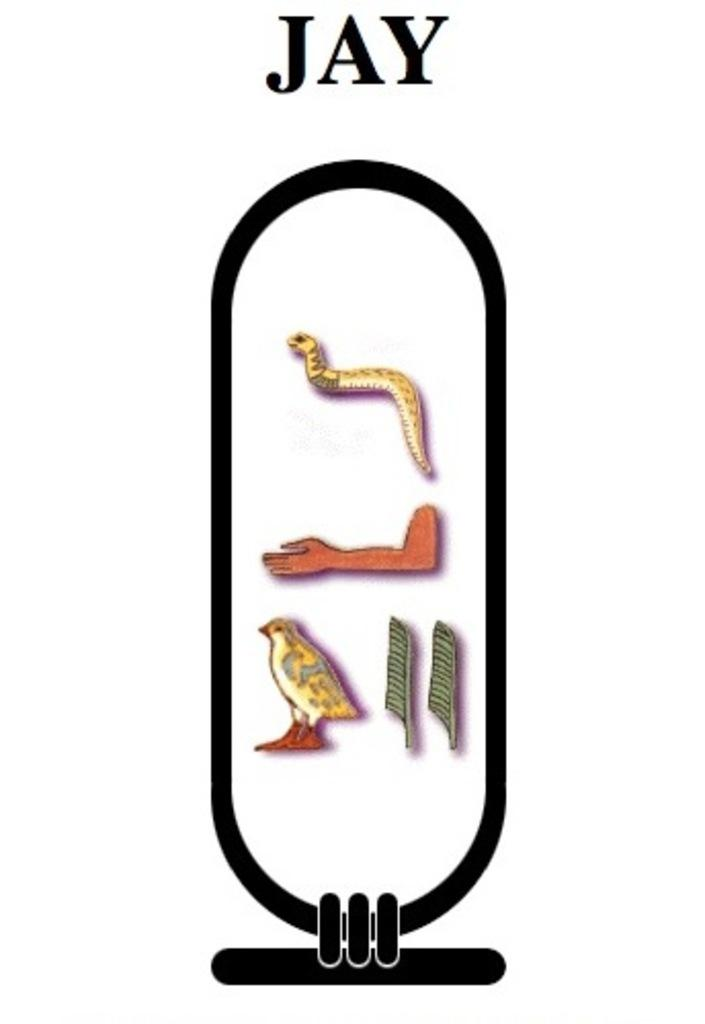What is the main feature of the image? There is a logo in the image. What is the color of the background behind the logo? The logo is on a white background. What animals or creatures are included in the logo? The logo contains a snake, a hand, a bird, and leaves. Is there any text present in the image? Yes, there is text in the image. What type of cup is being used to amplify the voice in the image? There is no cup or voice present in the image; it only features a logo with a snake, a hand, a bird, and leaves, along with some text. 